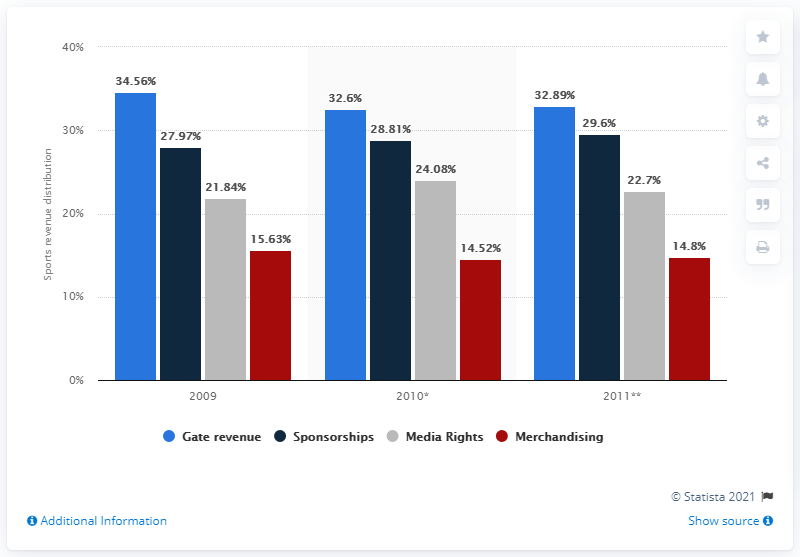Specify some key components in this picture. In 2011, merchandising generated approximately 14.8% of the company's total revenue. 